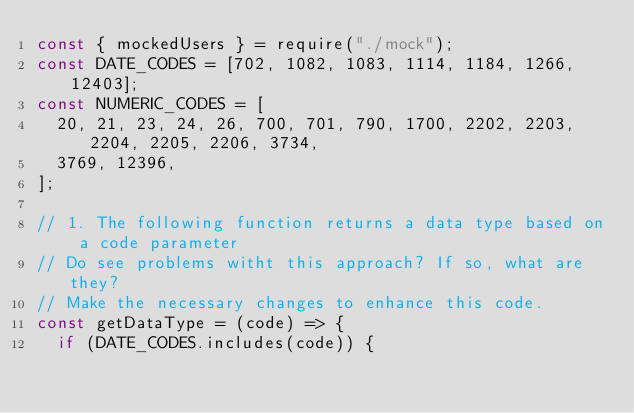<code> <loc_0><loc_0><loc_500><loc_500><_JavaScript_>const { mockedUsers } = require("./mock");
const DATE_CODES = [702, 1082, 1083, 1114, 1184, 1266, 12403];
const NUMERIC_CODES = [
  20, 21, 23, 24, 26, 700, 701, 790, 1700, 2202, 2203, 2204, 2205, 2206, 3734,
  3769, 12396,
];

// 1. The following function returns a data type based on a code parameter
// Do see problems witht this approach? If so, what are they?
// Make the necessary changes to enhance this code.
const getDataType = (code) => {
  if (DATE_CODES.includes(code)) {</code> 